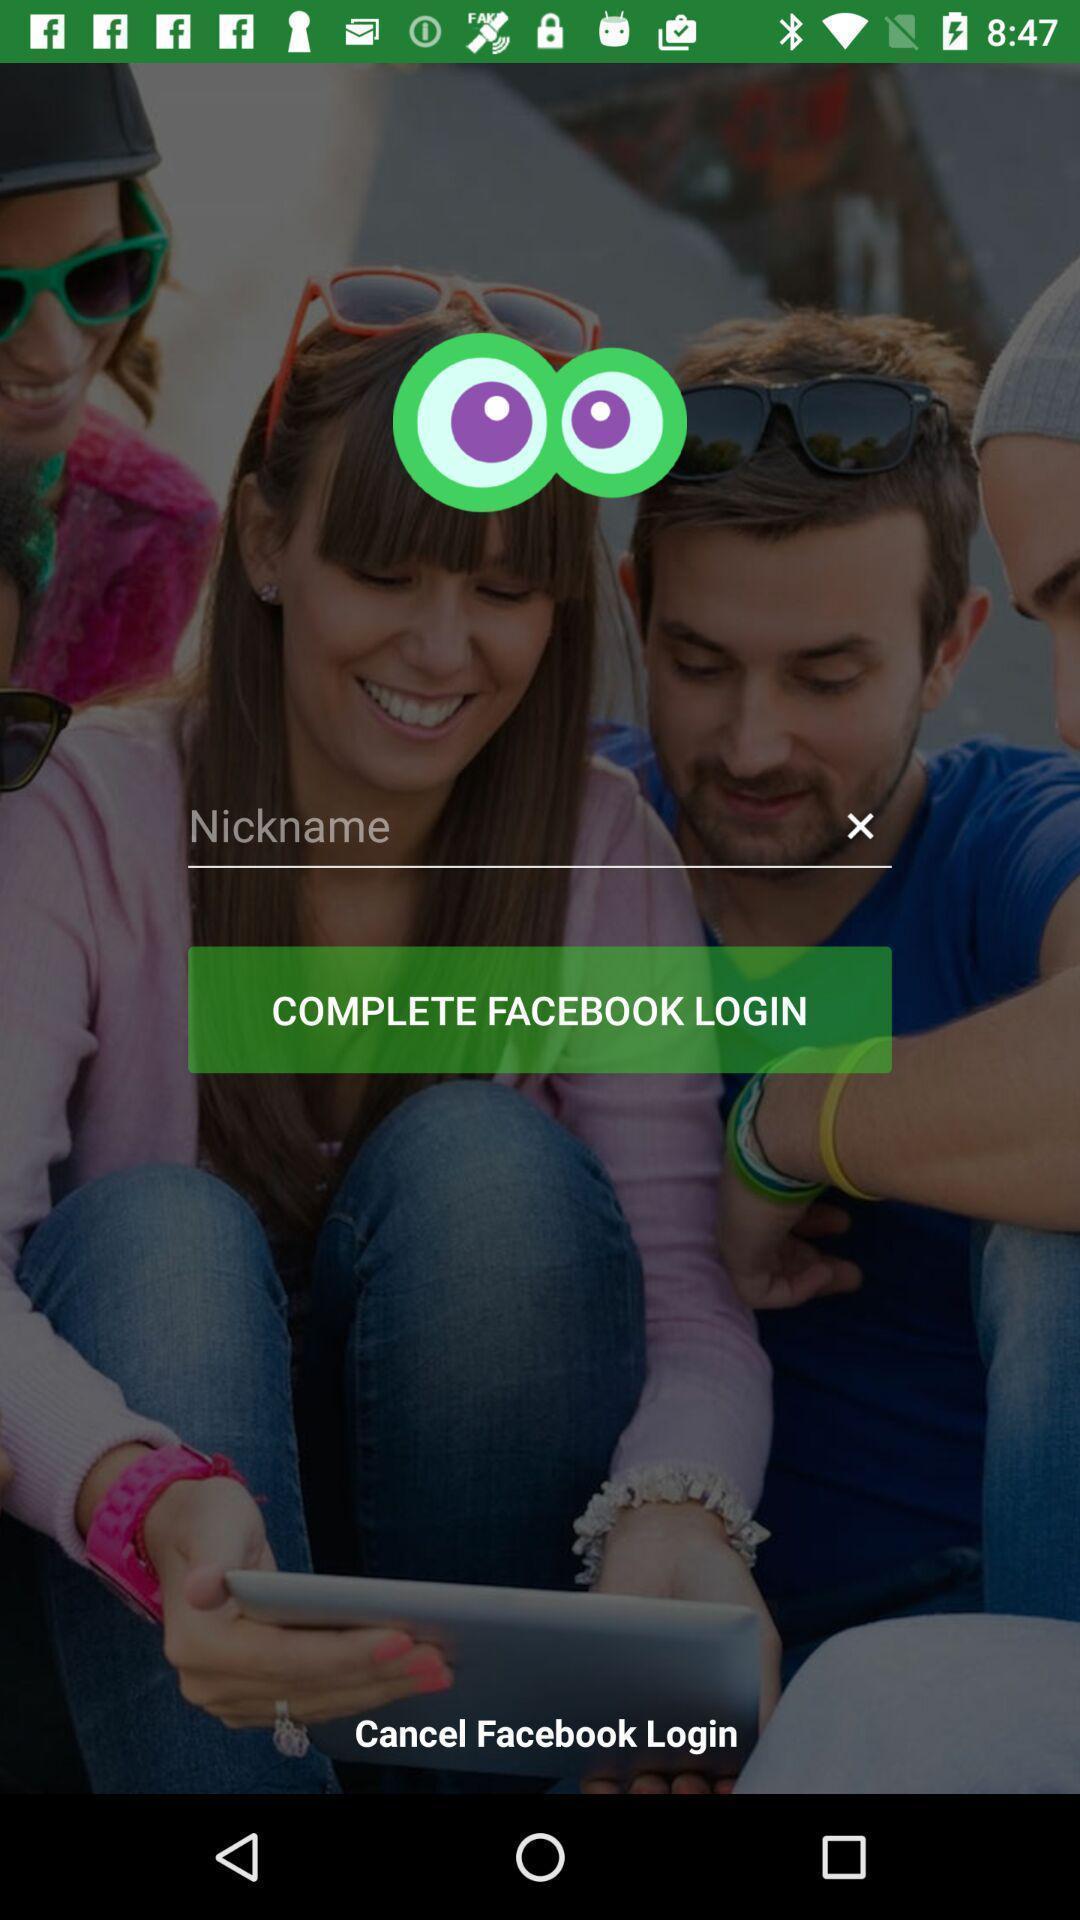Summarize the main components in this picture. Welcome page of a social application. 